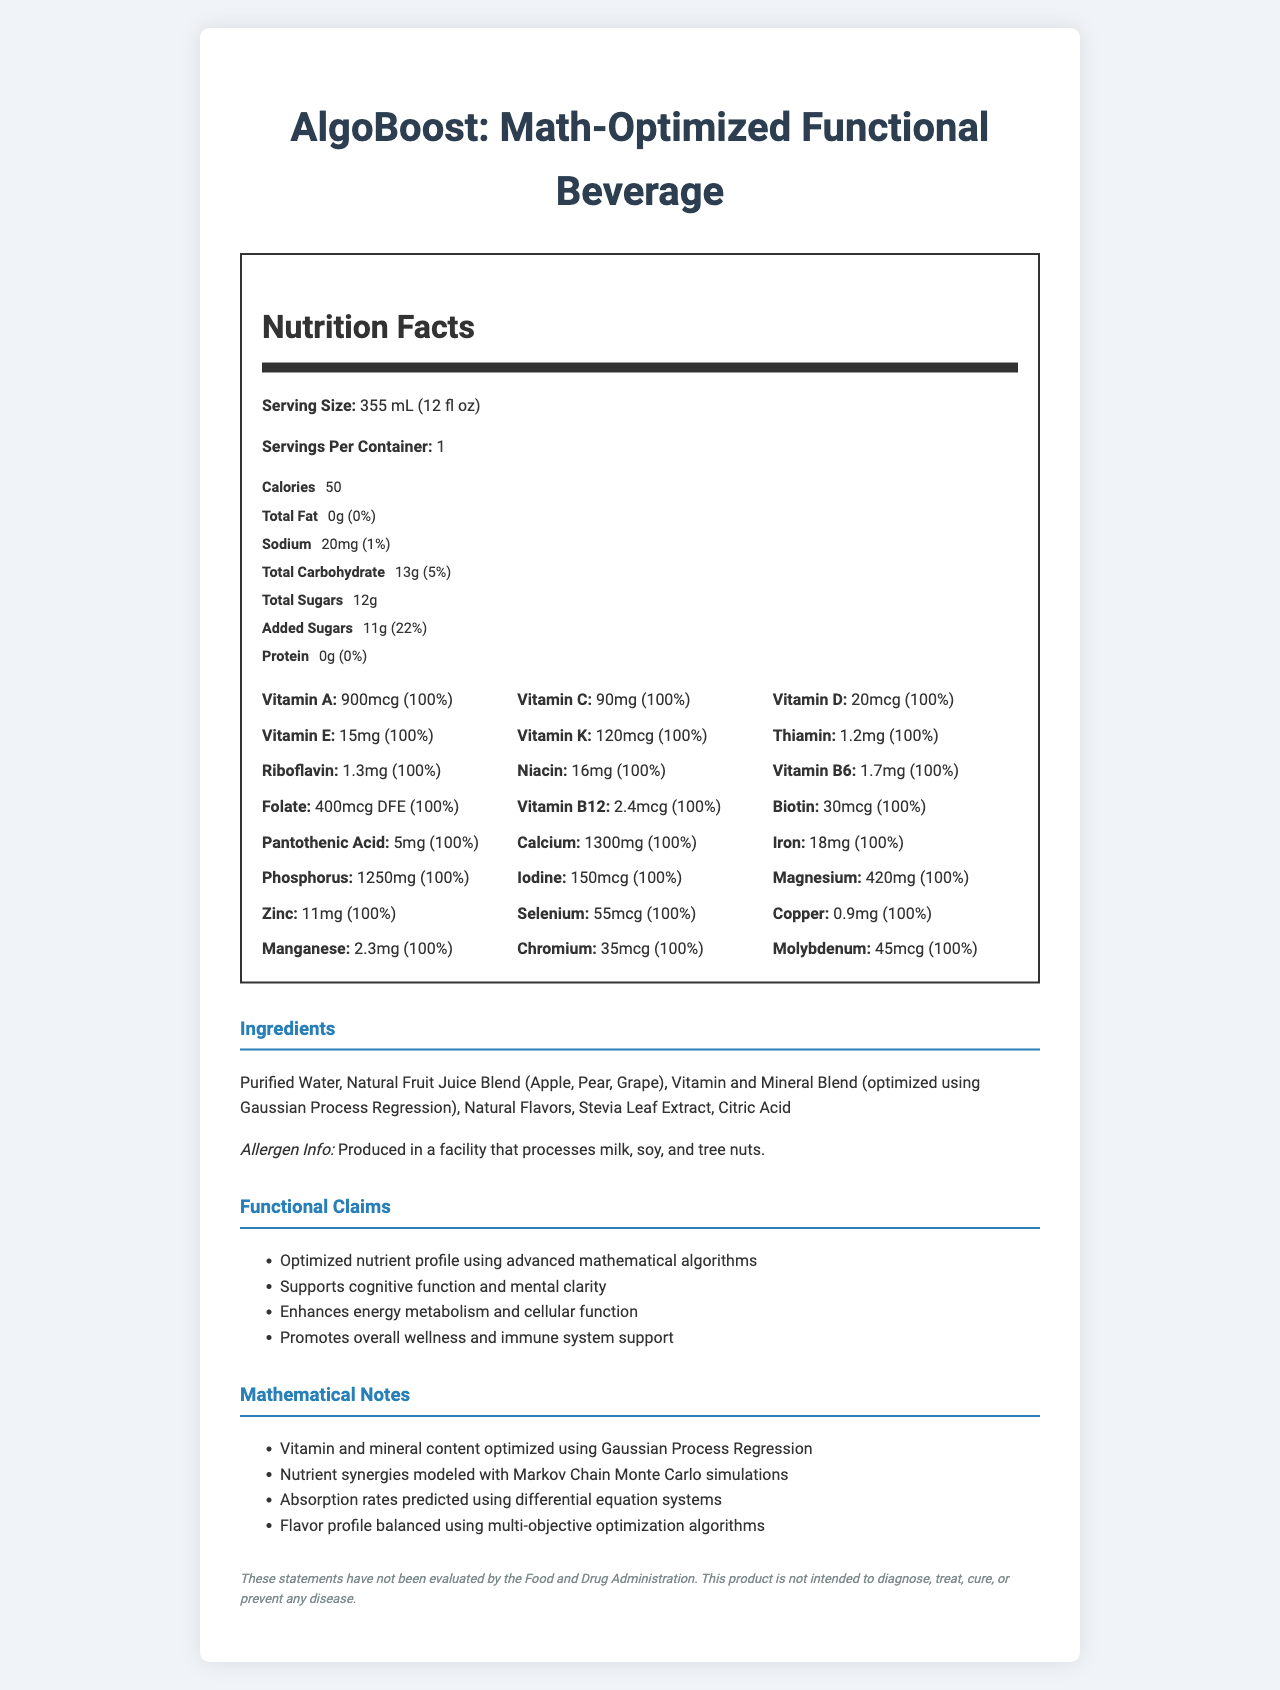what is the serving size of AlgoBoost? The serving size is explicitly listed as 355 mL (12 fl oz).
Answer: 355 mL (12 fl oz) how many calories are in one serving of AlgoBoost? The calories per serving is mentioned as 50 in the nutritional facts.
Answer: 50 what percentage of the daily value of added sugars does one serving of AlgoBoost contain? The added sugars daily value is listed as 22%.
Answer: 22% how many vitamins and minerals are listed in the nutritional facts section? There are 24 listed vitamins and minerals in the nutritional facts section.
Answer: 24 what type of facility is AlgoBoost produced in according to the allergen info? The allergen info mentions it is produced in a facility that processes milk, soy, and tree nuts.
Answer: A facility that processes milk, soy, and tree nuts which of the following vitamins are included in AlgoBoost? A. Vitamin B9 B. Vitamin E C. Vitamin C D. Vitamin A The nutritional facts list all these vitamins (A, C, E, and the folate form of B9).
Answer: A, B, C, D which mathematical model is used to optimize the vitamin and mineral blend? A. Markov Chain Monte Carlo B. Differential Equation Systems C. Gaussian Process Regression D. Multi-Objective Optimization The document explicitly mentions that the vitamin and mineral blend is optimized using Gaussian Process Regression.
Answer: C which ingredient is not part of AlgoBoost? 1. Stevia Leaf Extract 2. Phosphoric Acid 3. Citric Acid 4. Purified Water Phosphoric Acid is not listed among the ingredients.
Answer: 2 is the total carbohydrate content in one serving of AlgoBoost less than 10% of the daily value? The total carbohydrate daily value is 5%, which is less than 10%.
Answer: Yes what is the main claim made about the nutrient profile of AlgoBoost? The main claim about the nutrient profile is that it is optimized using advanced mathematical algorithms.
Answer: Optimized using advanced mathematical algorithms describe the functional claims of AlgoBoost. These claims are listed under the functional claims section of the document.
Answer: AlgoBoost claims to support cognitive function and mental clarity, enhance energy metabolism and cellular function, and promote overall wellness and immune system support. what flavors are used in AlgoBoost? The ingredient list includes Natural Flavors, without specifying variations.
Answer: Natural Flavors explain how the flavor profile of AlgoBoost is balanced. According to the mathematical notes, the flavor profile is achieved using multi-objective optimization algorithms.
Answer: The flavor profile is balanced using multi-objective optimization algorithms. how is the absorption rate of nutrients in AlgoBoost predicted? The mathematical notes mention that absorption rates are predicted using differential equation systems.
Answer: Using differential equation systems which nutrient is included in AlgoBoost but not explicitly listed in the label? The document provides a comprehensive list of nutrients, hence, it is not clear which nutrient might be excluded.
Answer: Cannot be determined what is the main idea of the AlgoBoost document? The main points cover the nutritional facts, ingredients, allergen info, functional claims, and the specific mathematical methods used for optimization and predictions in AlgoBoost.
Answer: The document provides detailed nutritional information about AlgoBoost, a functional beverage. It highlights the serving size, calories, vitamins, and minerals content optimized using mathematical algorithms like Gaussian Process Regression. The document also lists the ingredients, allergen information, functional claims, and mathematical notes describing the optimization and prediction models used. 